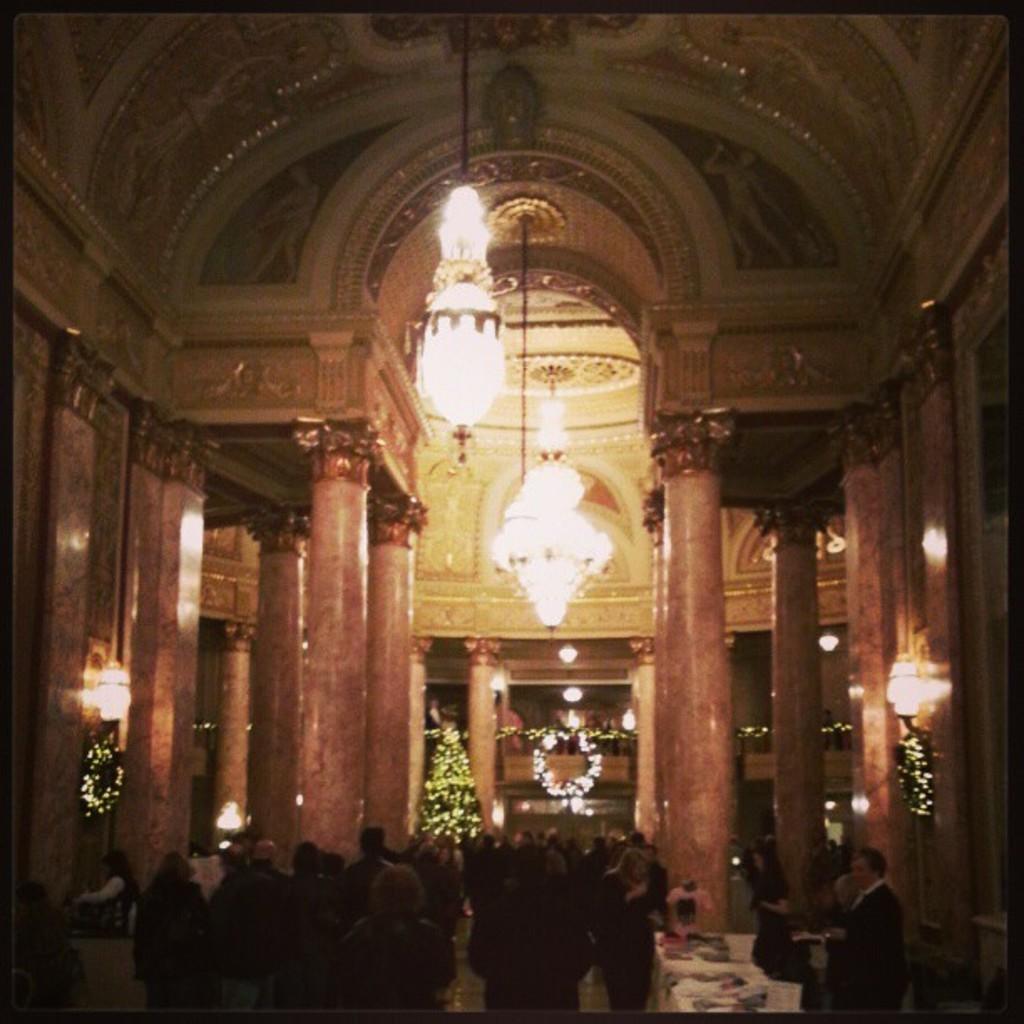Please provide a concise description of this image. Inside a palace there is a crowd and in the front there is a Christmas tree and the palace is beautifully decorated with lot of lights. 